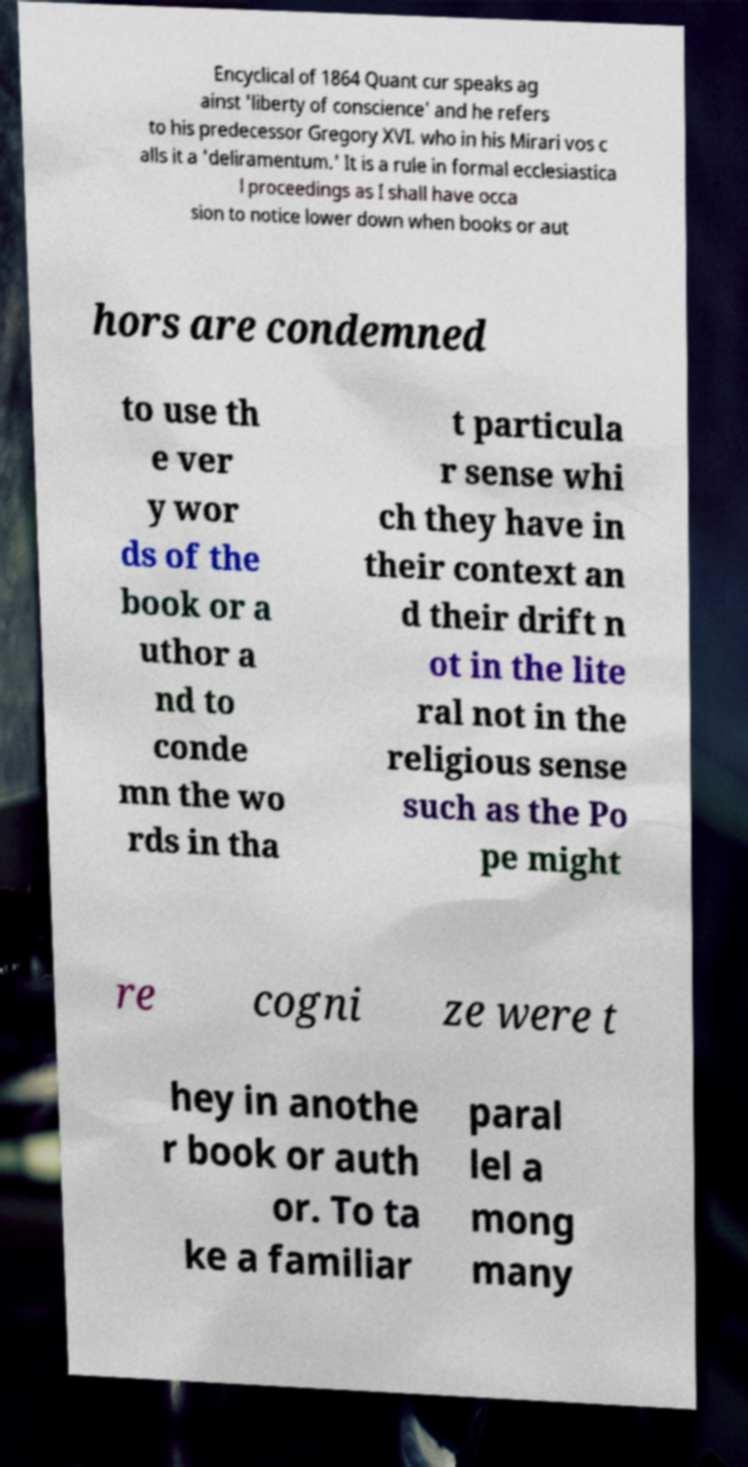Can you read and provide the text displayed in the image?This photo seems to have some interesting text. Can you extract and type it out for me? Encyclical of 1864 Quant cur speaks ag ainst 'liberty of conscience' and he refers to his predecessor Gregory XVI. who in his Mirari vos c alls it a 'deliramentum.' It is a rule in formal ecclesiastica l proceedings as I shall have occa sion to notice lower down when books or aut hors are condemned to use th e ver y wor ds of the book or a uthor a nd to conde mn the wo rds in tha t particula r sense whi ch they have in their context an d their drift n ot in the lite ral not in the religious sense such as the Po pe might re cogni ze were t hey in anothe r book or auth or. To ta ke a familiar paral lel a mong many 